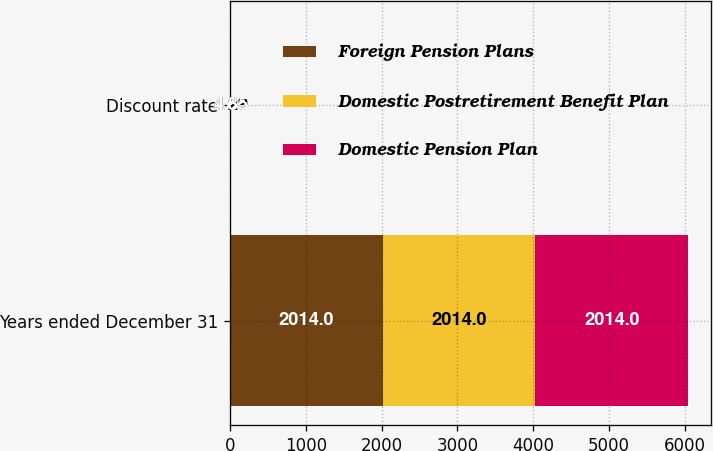Convert chart to OTSL. <chart><loc_0><loc_0><loc_500><loc_500><stacked_bar_chart><ecel><fcel>Years ended December 31<fcel>Discount rate<nl><fcel>Foreign Pension Plans<fcel>2014<fcel>4.85<nl><fcel>Domestic Postretirement Benefit Plan<fcel>2014<fcel>4.29<nl><fcel>Domestic Pension Plan<fcel>2014<fcel>4.85<nl></chart> 